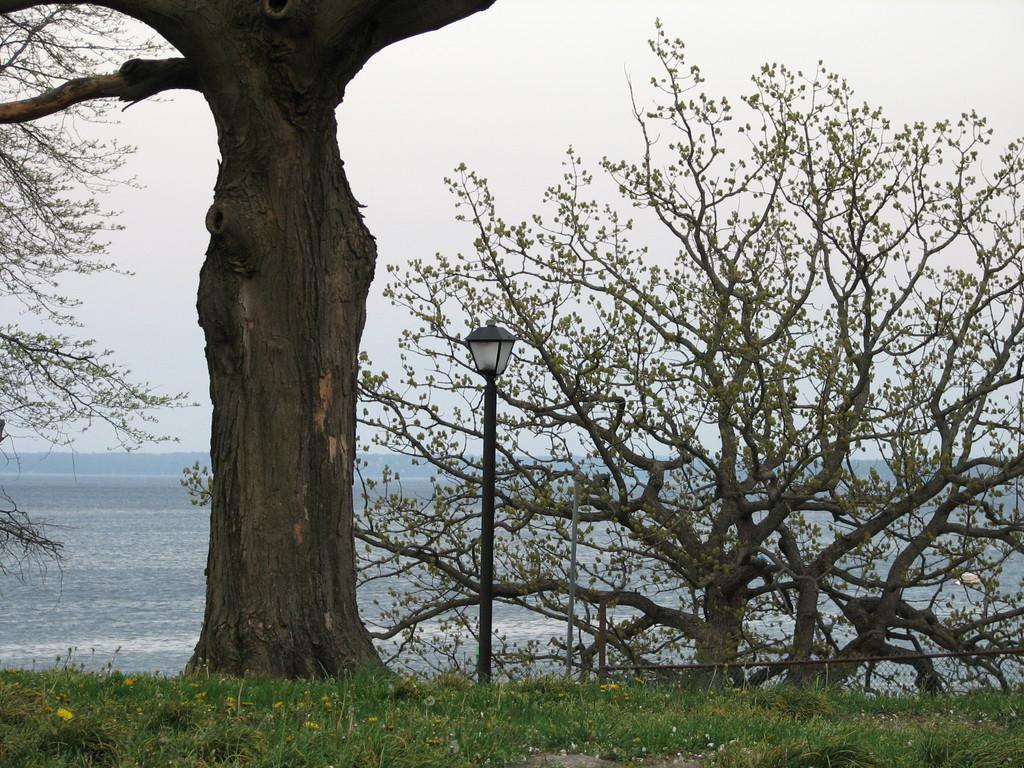Could you give a brief overview of what you see in this image? In this image we can see some trees, flowers and grass on the ground and there is a pole light and we can see the water in the background and we can see the sky. 